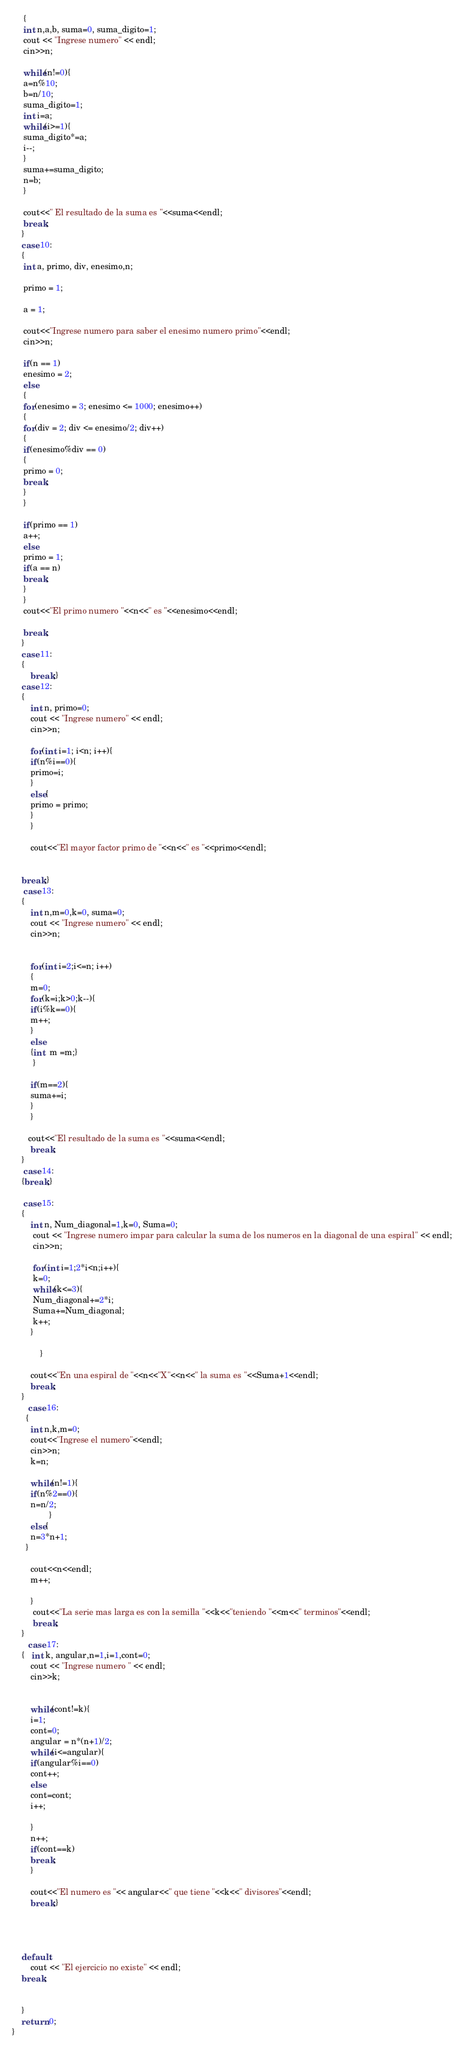<code> <loc_0><loc_0><loc_500><loc_500><_C++_>     {
     int n,a,b, suma=0, suma_digito=1;
     cout << "Ingrese numero" << endl;
     cin>>n;

     while(n!=0){
     a=n%10;
     b=n/10;
     suma_digito=1;
     int i=a;
     while(i>=1){
     suma_digito*=a;
     i--;
     }
     suma+=suma_digito;
     n=b;
     }

     cout<<" El resultado de la suma es "<<suma<<endl;
     break;
    }
    case 10:
    {
     int a, primo, div, enesimo,n;

     primo = 1;

     a = 1;

     cout<<"Ingrese numero para saber el enesimo numero primo"<<endl;
     cin>>n;

     if(n == 1)
     enesimo = 2;
     else
     {
     for(enesimo = 3; enesimo <= 1000; enesimo++)
     {
     for(div = 2; div <= enesimo/2; div++)
     {
     if(enesimo%div == 0)
     {
     primo = 0;
     break;
     }
     }

     if(primo == 1)
     a++;
     else
     primo = 1;
     if(a == n)
     break;
     }
     }
     cout<<"El primo numero "<<n<<" es "<<enesimo<<endl;

     break;
    }
    case 11:
    {
        break;}
    case 12:
    {
        int n, primo=0;
        cout << "Ingrese numero" << endl;
        cin>>n;

        for(int i=1; i<n; i++){
        if(n%i==0){
        primo=i;
        }
        else{
        primo = primo;
        }
        }

        cout<<"El mayor factor primo de "<<n<<" es "<<primo<<endl;


    break;}
     case 13:
    {
        int n,m=0,k=0, suma=0;
        cout << "Ingrese numero" << endl;
        cin>>n;


        for(int i=2;i<=n; i++)
        {
        m=0;
        for(k=i;k>0;k--){
        if(i%k==0){
        m++;
        }
        else
        {int  m =m;}
         }

        if(m==2){
        suma+=i;
        }
        }

       cout<<"El resultado de la suma es "<<suma<<endl;
        break;
    }
     case 14:
    {break;}

     case 15:
    {
        int n, Num_diagonal=1,k=0, Suma=0;
         cout << "Ingrese numero impar para calcular la suma de los numeros en la diagonal de una espiral" << endl;
         cin>>n;

         for(int i=1;2*i<n;i++){
         k=0;
         while(k<=3){
         Num_diagonal+=2*i;
         Suma+=Num_diagonal;
         k++;
        }

            }

        cout<<"En una espiral de "<<n<<"X"<<n<<" la suma es "<<Suma+1<<endl;
        break;
    }
       case 16:
      {
        int n,k,m=0;
        cout<<"Ingrese el numero"<<endl;
        cin>>n;
        k=n;

        while(n!=1){
        if(n%2==0){
        n=n/2;
                }
        else{
        n=3*n+1;
      }

        cout<<n<<endl;
        m++;

        }
         cout<<"La serie mas larga es con la semilla "<<k<<"teniendo "<<m<<" terminos"<<endl;
         break;
    }
       case 17:
    {   int k, angular,n=1,i=1,cont=0;
        cout << "Ingrese numero " << endl;
        cin>>k;


        while(cont!=k){
        i=1;
        cont=0;
        angular = n*(n+1)/2;
        while(i<=angular){
        if(angular%i==0)
        cont++;
        else
        cont=cont;
        i++;

        }
        n++;
        if(cont==k)
        break;
        }

        cout<<"El numero es "<< angular<<" que tiene "<<k<<" divisores"<<endl;
        break;}




    default:
        cout << "El ejercicio no existe" << endl;
    break;


    }
    return 0;
}
</code> 